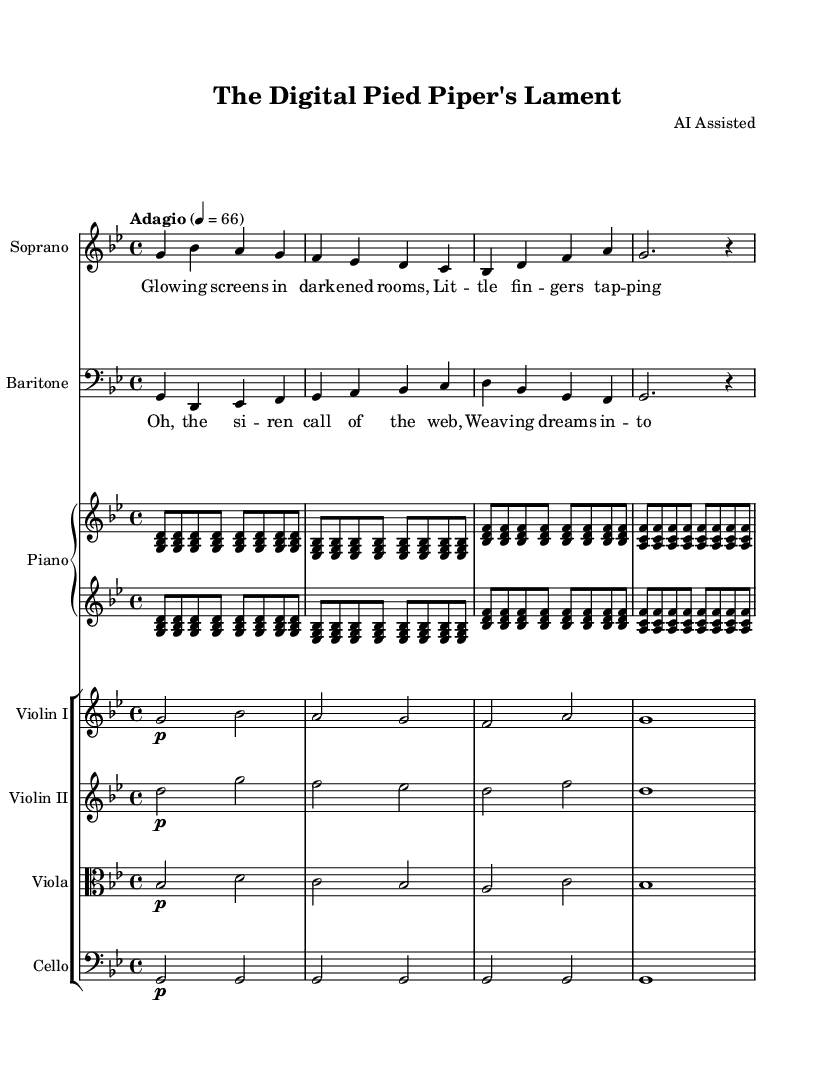What is the key signature of this music? The key signature indicates that the music is in G minor, which has two flats (B flat and E flat). This is noted at the beginning of the staff.
Answer: G minor What is the time signature of the piece? The time signature specified at the beginning of the score is 4/4, indicating four beats in each measure, with the quarter note receiving one beat.
Answer: 4/4 What is the tempo marking for this opera? The tempo marking shown in the score is "Adagio," which means a slow pace, typically around 66 beats per minute. This is noted directly in the score under the global properties.
Answer: Adagio How many instruments are included in this opera score? The score includes a total of six instruments: Soprano, Baritone, Piano, Violin I, Violin II, Viola, and Cello. Each is noted under separate staff groups in the score.
Answer: Seven What is the title of this operatic adaptation? The title of the opera is "The Digital Pied Piper's Lament," as stated in the header of the sheet music.
Answer: The Digital Pied Piper's Lament Who is credited as the composer of this piece? The composer is noted as "AI Assisted" in the header of the music sheet. This indicates that the piece is created with assistance from AI technology.
Answer: AI Assisted What is the theme of this operatic adaptation? The operatic adaptation focuses on themes of digital addiction, as implied by the juxtaposition of the classic children's story and modern technological issues reflected in the lyrics and title.
Answer: Digital addiction 